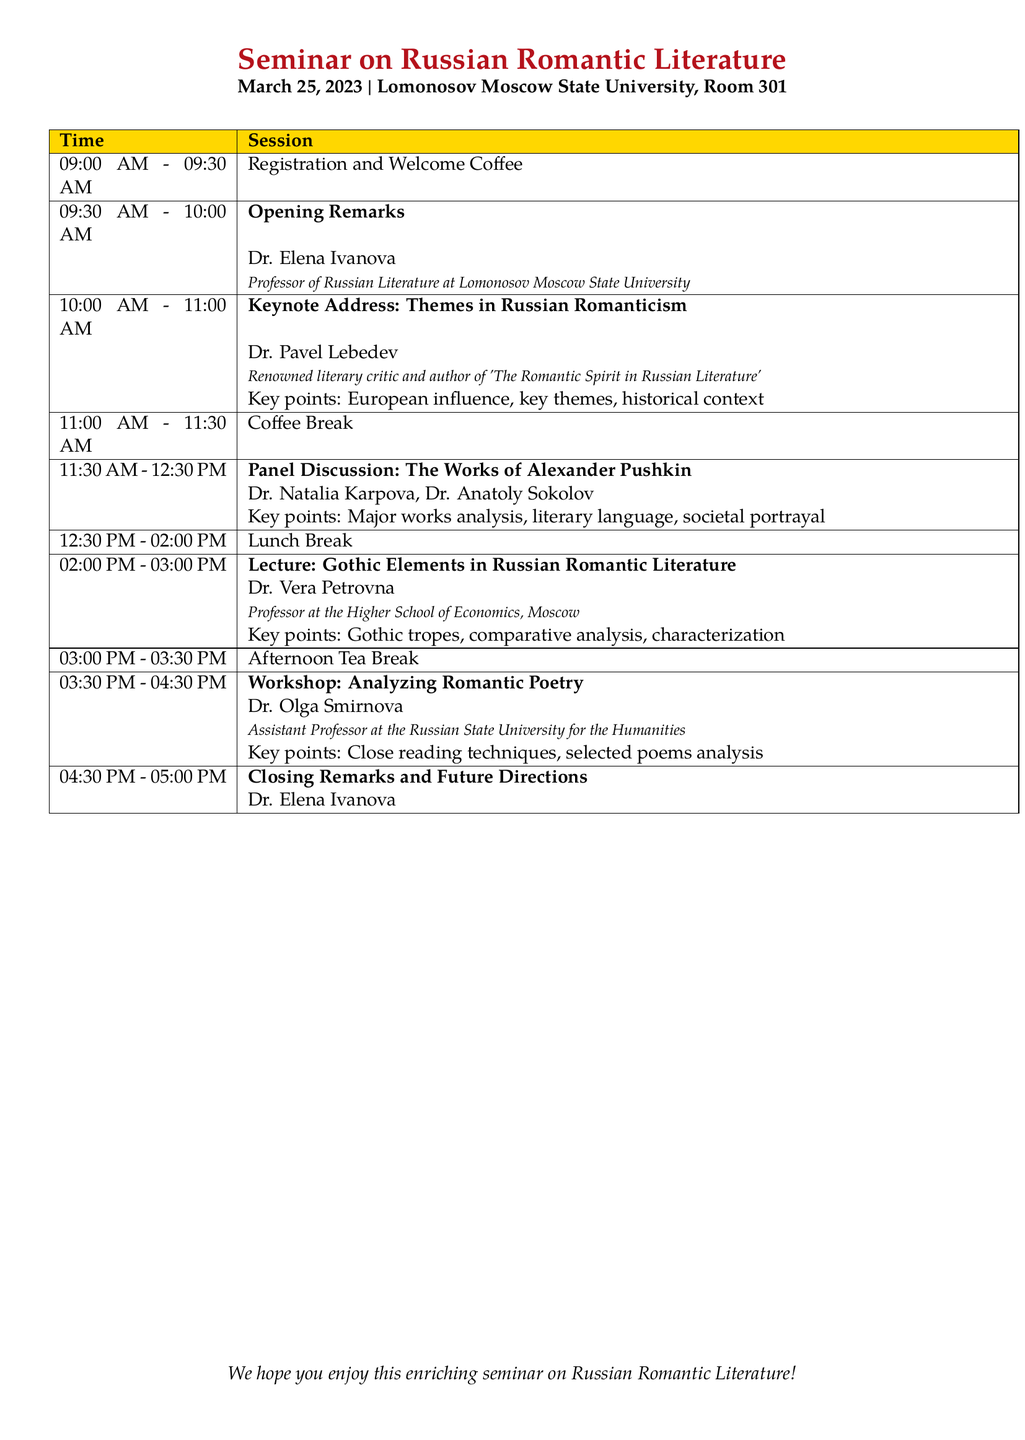What date is the seminar scheduled for? The date is explicitly mentioned in the document as March 25, 2023.
Answer: March 25, 2023 Who is the keynote speaker? The document provides the name of the keynote speaker as Dr. Pavel Lebedev.
Answer: Dr. Pavel Lebedev What time does the coffee break occur? The document specifies the timing for the coffee break as 11:00 AM - 11:30 AM.
Answer: 11:00 AM - 11:30 AM How many speakers are involved in the panel discussion? By counting the speakers listed, the panel discussion has two speakers: Dr. Natalia Karpova and Dr. Anatoly Sokolov.
Answer: Two What is the main topic of Dr. Vera Petrovna's lecture? The document states that her lecture is focused on Gothic Elements in Russian Romantic Literature.
Answer: Gothic Elements in Russian Romantic Literature What are the key discussion points during the workshop led by Dr. Olga Smirnova? The key points of the workshop include close reading techniques and selected poems analysis.
Answer: Close reading techniques, selected poems analysis Who provides the opening remarks? The opening remarks are delivered by Dr. Elena Ivanova as per the schedule.
Answer: Dr. Elena Ivanova What room is the seminar held in? The venue is specified in the document as Room 301 at Lomonosov Moscow State University.
Answer: Room 301 